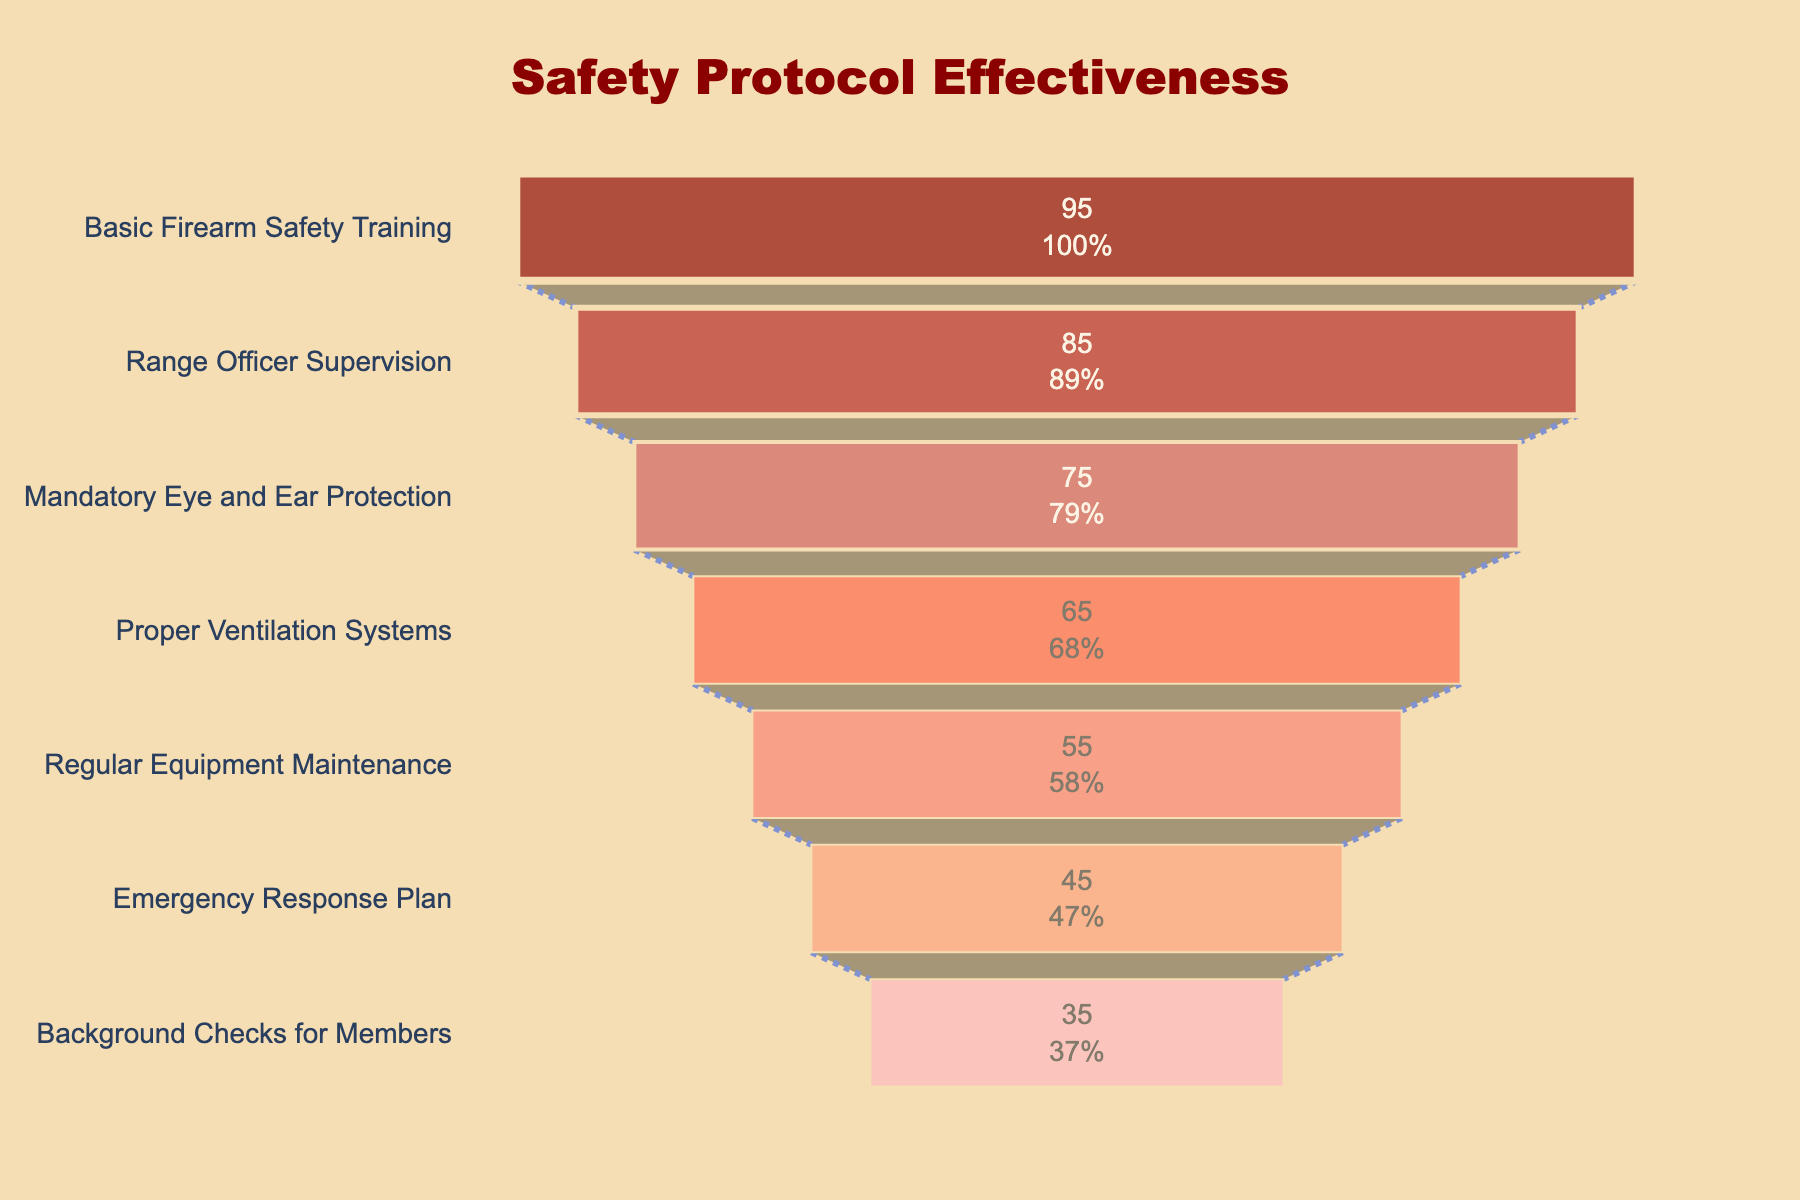What is the title of the funnel chart? The title is displayed at the top of the funnel chart. It reads "Safety Protocol Effectiveness" in a large, prominent font.
Answer: Safety Protocol Effectiveness How many safety protocols are listed in the funnel chart? The funnel chart displays seven different safety protocols, each represented by a distinct color band.
Answer: Seven Which safety protocol shows the highest incident reduction rate? The protocol with the highest incident reduction rate is at the widest part of the funnel at the top. It is "Basic Firearm Safety Training" with a rate of 95%.
Answer: Basic Firearm Safety Training What is the difference in incident reduction rates between Range Officer Supervision and Regular Equipment Maintenance? Observe their respective positions on the funnel chart and subtract the incident reduction rates of Regular Equipment Maintenance (55%) from that of Range Officer Supervision (85%). This difference is 85% - 55%.
Answer: 30% Which protocol has a lower incident reduction rate: Mandatory Eye and Ear Protection or Proper Ventilation Systems? Locate both protocols on the funnel chart and compare their incident reduction rates. Mandatory Eye and Ear Protection is at 75%, while Proper Ventilation Systems is at 65%. So, Proper Ventilation Systems has a lower rate.
Answer: Proper Ventilation Systems What is the average incident reduction rate of all listed safety protocols? Sum all the incident reduction rates (95% + 85% + 75% + 65% + 55% + 45% + 35%) and then divide by the number of protocols (7). The calculation is (95 + 85 + 75 + 65 + 55 + 45 + 35)/7.
Answer: 65% Which safety protocol shows an incident reduction rate of 45%? Find the protocol at the point where the funnel chart indicates a 45% incident reduction rate. It is the "Emergency Response Plan."
Answer: Emergency Response Plan How much more effective is Basic Firearm Safety Training compared to Background Checks for Members in terms of incident reduction rate? Compare the incident reduction rates of Basic Firearm Safety Training (95%) and Background Checks for Members (35%). The difference is 95% - 35%.
Answer: 60% What is the least effective safety protocol in the funnel chart? The least effective protocol will be at the narrowest part of the funnel towards the bottom. It is "Background Checks for Members" with a 35% incident reduction rate.
Answer: Background Checks for Members If you implemented both Range Officer Supervision and Background Checks for Members, what is the combined incident reduction rate? The combined effect when implementing both is not additive but for the sake of this question, sum their rates: 85% (Range Officer Supervision) + 35% (Background Checks).
Answer: 120% 